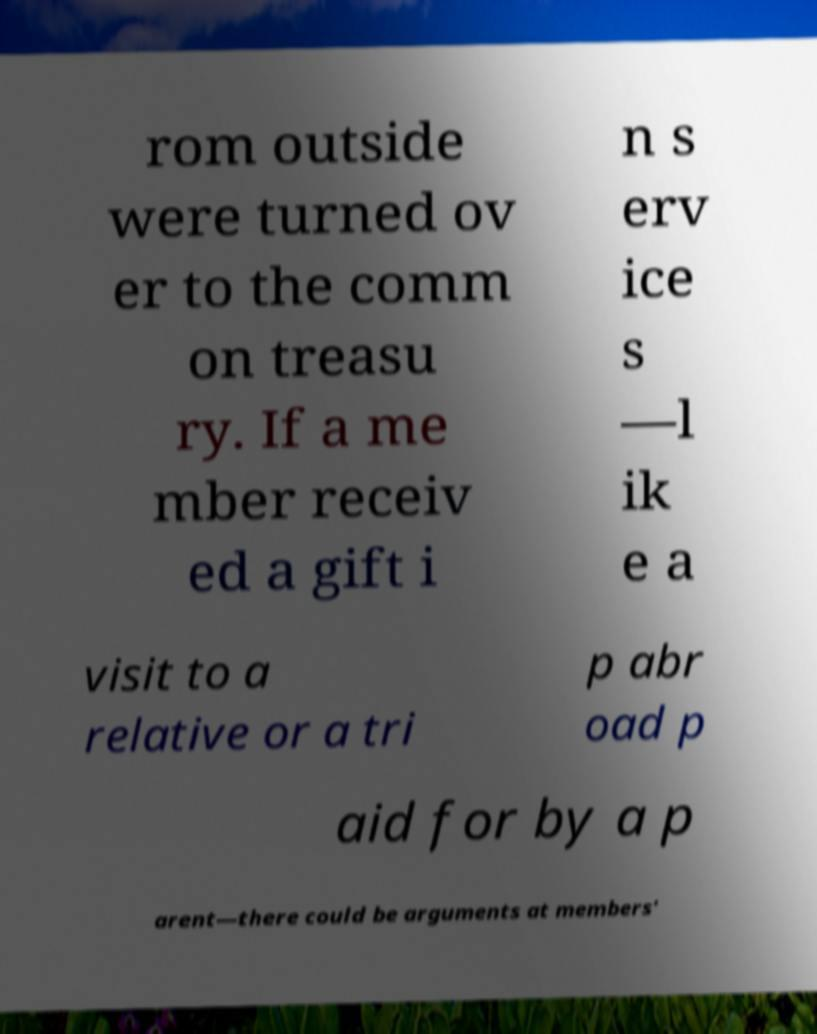Can you read and provide the text displayed in the image?This photo seems to have some interesting text. Can you extract and type it out for me? rom outside were turned ov er to the comm on treasu ry. If a me mber receiv ed a gift i n s erv ice s —l ik e a visit to a relative or a tri p abr oad p aid for by a p arent—there could be arguments at members' 